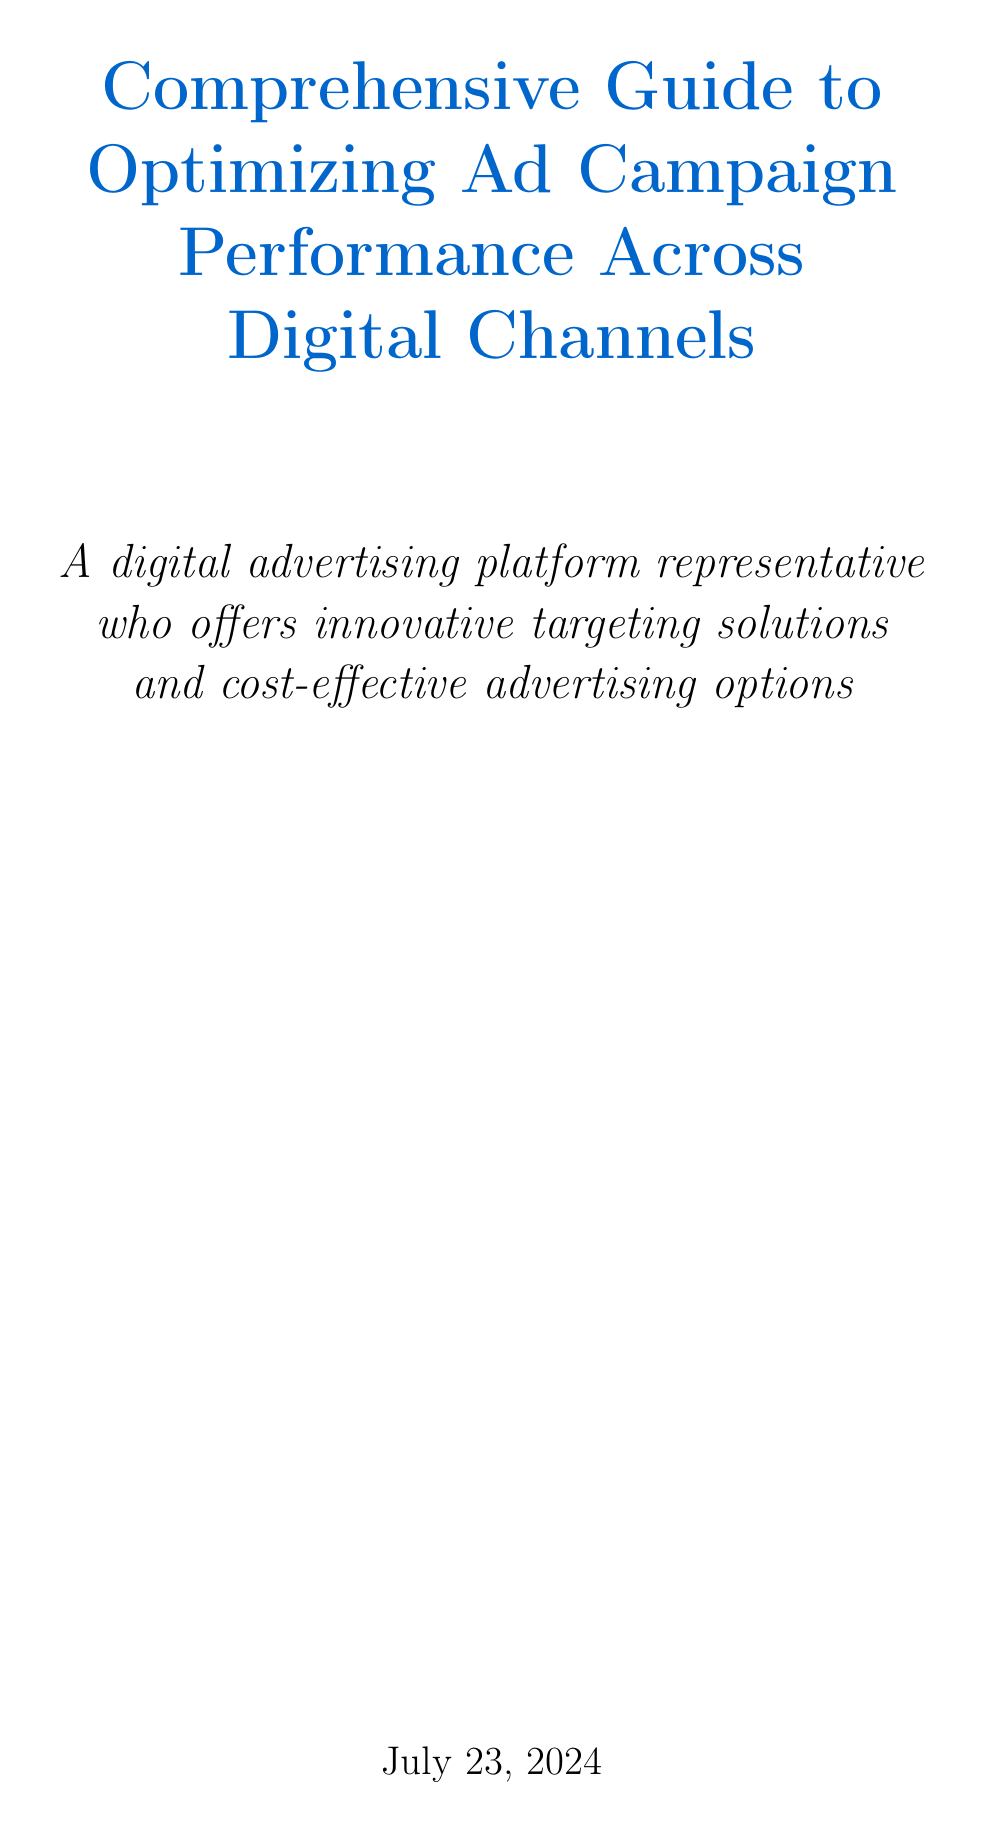What is the title of the manual? The title is stated in the title section of the document, which provides the main subject of the manual.
Answer: Comprehensive Guide to Optimizing Ad Campaign Performance Across Digital Channels What is the importance of effective optimization mentioned in the introduction? The importance is highlighted in the introduction section, specifically addressing the goal of maximizing ROI and reaching target audiences.
Answer: Maximizing ROI What tool is suggested for audience targeting in Google Ads? The document mentions tools and strategies for optimizing performance in ads, specifically for Google Ads.
Answer: Smart Bidding How many sections are there under Cross-Channel Optimization Strategies? The document outlines the structure of the chapters and sections, indicating the number of sections provided.
Answer: Three What does the manual suggest for conducting systematic testing? The document lists various strategies for improving campaign performance, among which systematic testing is mentioned.
Answer: A/B tests Which platform's reporting features are recommended for comprehensive reporting? The reporting section of the document discusses specific tools and features that aid in reporting.
Answer: Google Data Studio What is emphasized for optimizing ad copy for B2B audiences? The document highlights specific strategies tailored for different audience types in advertising optimization.
Answer: LinkedIn Advertising How can advertisers implement cross-channel audience targeting? The manual provides strategies on audience segmentation, one of the key aspects covered in the Cross-Channel Optimization Strategies section.
Answer: AI-driven audience insights 